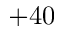<formula> <loc_0><loc_0><loc_500><loc_500>+ 4 0</formula> 